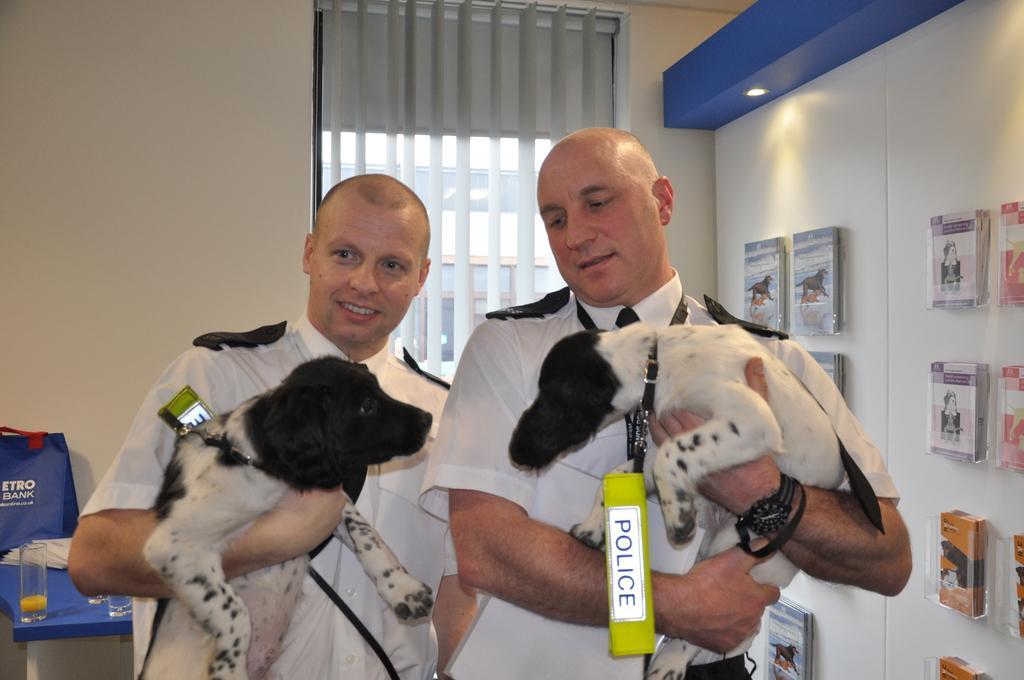Describe this image in one or two sentences. Two men are standing and holding the two dogs there are tags police on the neck of this two dogs These two dogs are in black and white color these two people are wearing white color dresses and behind them there is a glass wall on the right there are few books about animals. 